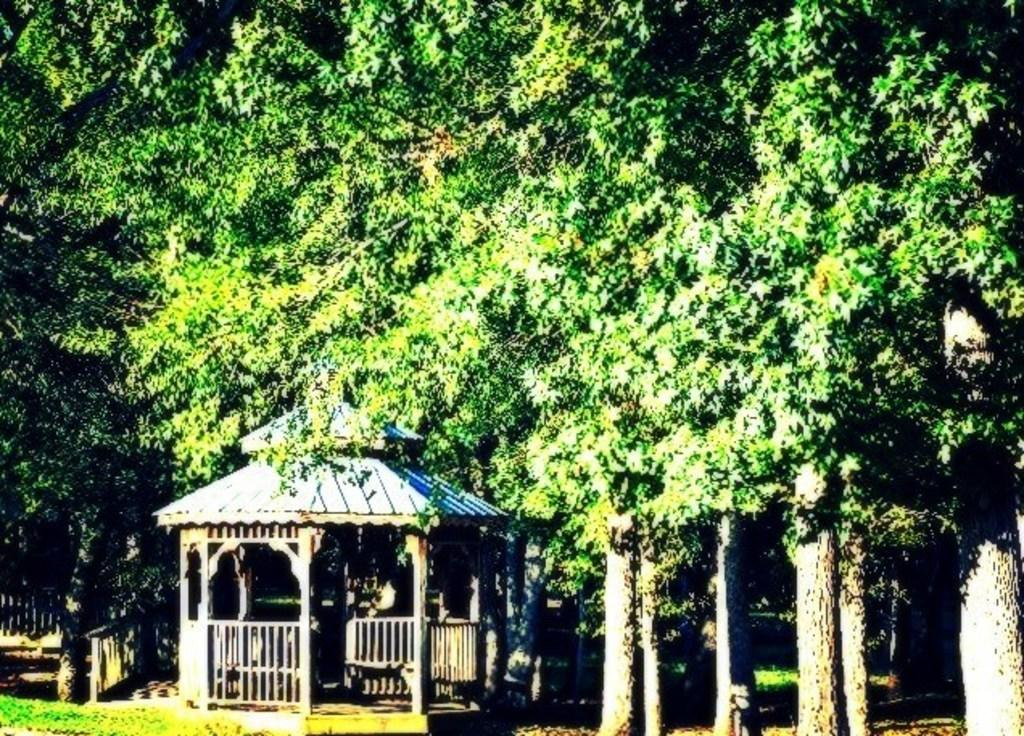What is the main structure in the center of the image? There is a house in the center of the image. What is located near the house? There is a fence in the image. What type of vegetation can be seen in the background of the image? There are trees in the background of the image. What type of ground surface is visible at the bottom of the image? There is grass visible at the bottom of the image. Where is the seat located in the image? There is no seat present in the image. What is the head of the person doing in the image? There is no person or head present in the image. 